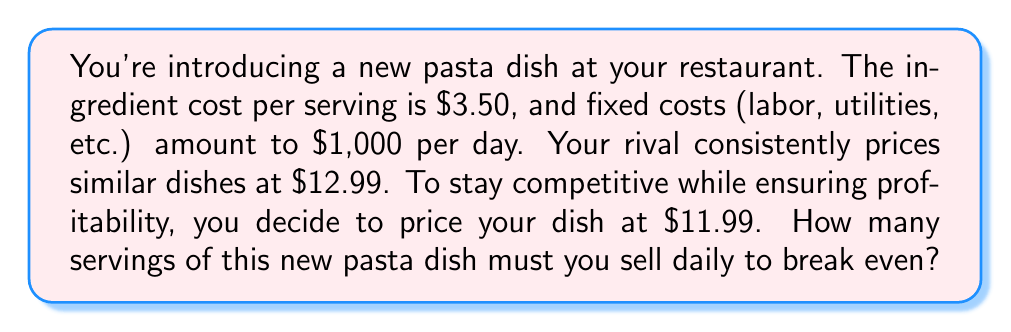Give your solution to this math problem. Let's approach this step-by-step using the break-even analysis formula:

1) First, let's define our variables:
   $p$ = price per unit (serving) = $11.99
   $v$ = variable cost per unit = $3.50
   $F$ = fixed costs = $1,000
   $x$ = number of units (servings) to break even

2) The break-even formula is:
   $$ F + vx = px $$

3) Substituting our values:
   $$ 1000 + 3.50x = 11.99x $$

4) Simplify the right side:
   $$ 1000 + 3.50x = 11.99x $$

5) Subtract 3.50x from both sides:
   $$ 1000 = 11.99x - 3.50x = 8.49x $$

6) Divide both sides by 8.49:
   $$ \frac{1000}{8.49} = x $$

7) Calculate:
   $$ x \approx 117.79 $$

8) Since we can't sell partial servings, we round up to the nearest whole number:
   $$ x = 118 $$

Therefore, you need to sell 118 servings daily to break even.
Answer: 118 servings 